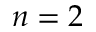Convert formula to latex. <formula><loc_0><loc_0><loc_500><loc_500>n = 2</formula> 